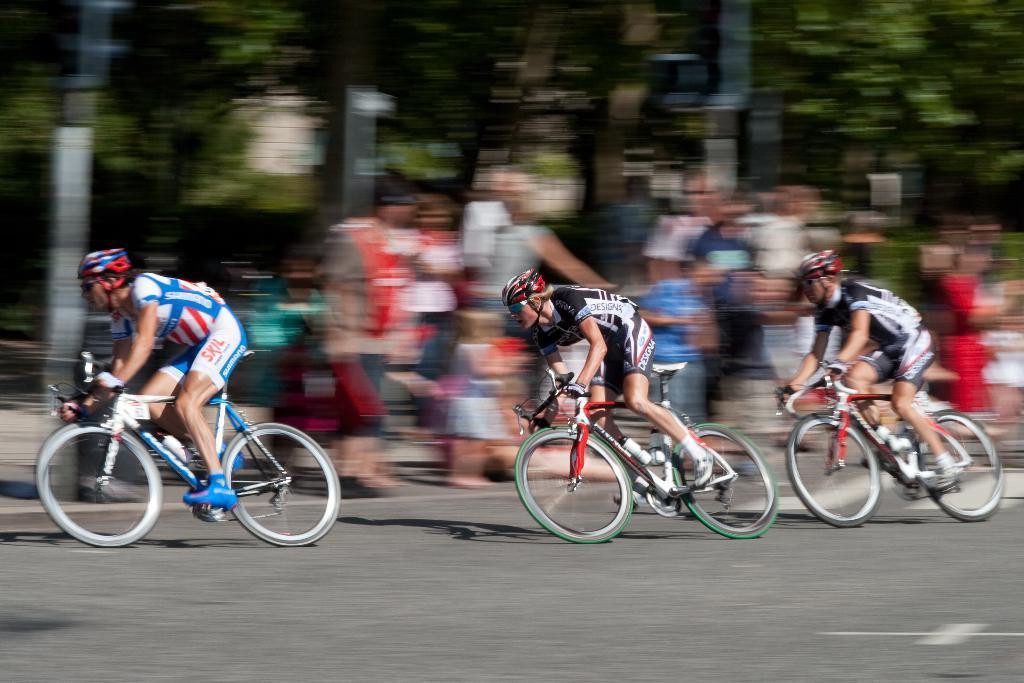Could you give a brief overview of what you see in this image? Here in this picture we can see three people riding bicycles on the track and we can see all of them are wearing gloves, goggles and helmet and beside them we can see people standing and other plants and trees in blurry manner. 